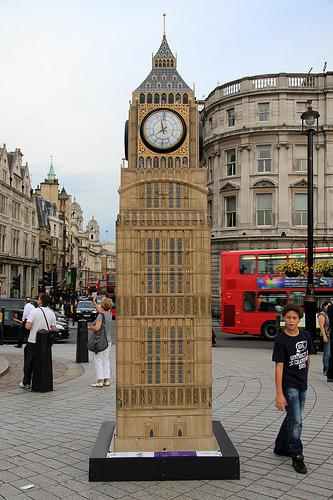Question: what color is the boy's shirt?
Choices:
A. White.
B. Gray.
C. Black.
D. Red.
Answer with the letter. Answer: C Question: what is in the background?
Choices:
A. Trees.
B. Mountains.
C. Buildings.
D. Sunset.
Answer with the letter. Answer: C Question: what is on the statue?
Choices:
A. A bird.
B. A clock.
C. Bird poop.
D. Water.
Answer with the letter. Answer: B Question: who is near the statue?
Choices:
A. A boy.
B. A girl.
C. A man.
D. A woman.
Answer with the letter. Answer: A Question: why is there a statue?
Choices:
A. Decoration.
B. To commemorate someone.
C. For display.
D. A vain person wanted a statue of themselves.
Answer with the letter. Answer: C Question: where is the clock?
Choices:
A. Middle of the statue.
B. East side of the statue.
C. Near the top of the statue.
D. West side of the statue.
Answer with the letter. Answer: C 